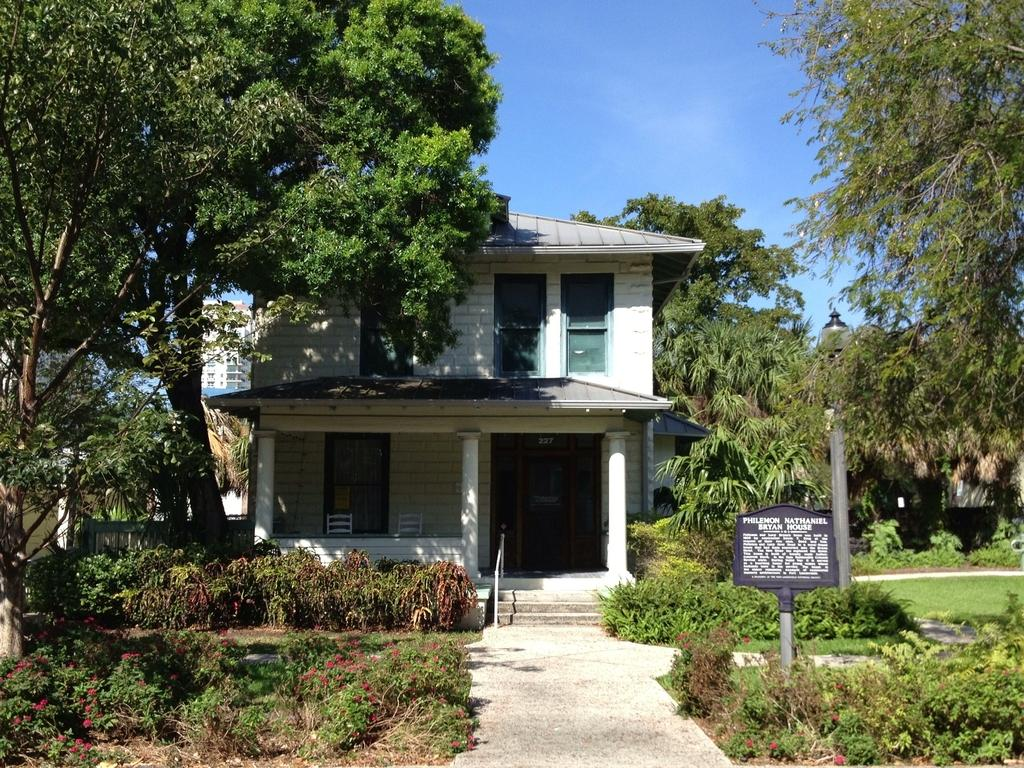What is the main subject of the image? The main subject of the image is the front view of a house. What type of vegetation is present in front of the house? There is grass and plants in front of the house. What other objects can be seen beside the house? There are trees and a lamp post beside the house. What is visible behind the house? There is a building behind the house. What type of cloth is draped over the head of the house in the image? There is no cloth draped over the head of the house in the image, as houses do not have heads. 